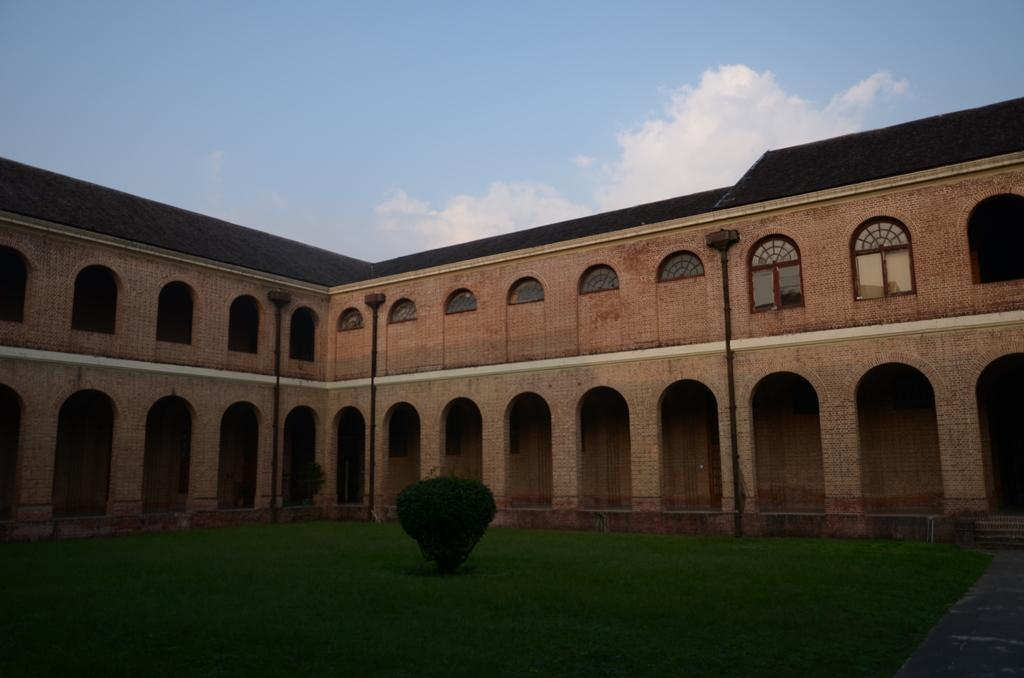What type of vegetation is present in the image? There is grass and a plant in the image in the image. What type of structure can be seen in the image? There is a building with windows in the image. What else can be found in the image besides the vegetation and structure? There are pipes in the image. What can be seen in the background of the image? The sky is visible in the background of the image, and there are clouds in the sky. What type of instrument is being played by the nation in the image? There is no nation or instrument present in the image. Can you see any feathers in the image? There are no feathers visible in the image. 